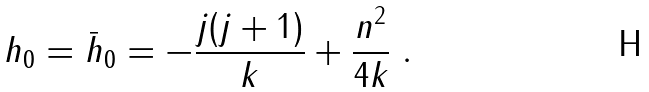Convert formula to latex. <formula><loc_0><loc_0><loc_500><loc_500>h _ { 0 } = \bar { h } _ { 0 } = - \frac { j ( j + 1 ) } { k } + \frac { n ^ { 2 } } { 4 k } \ .</formula> 